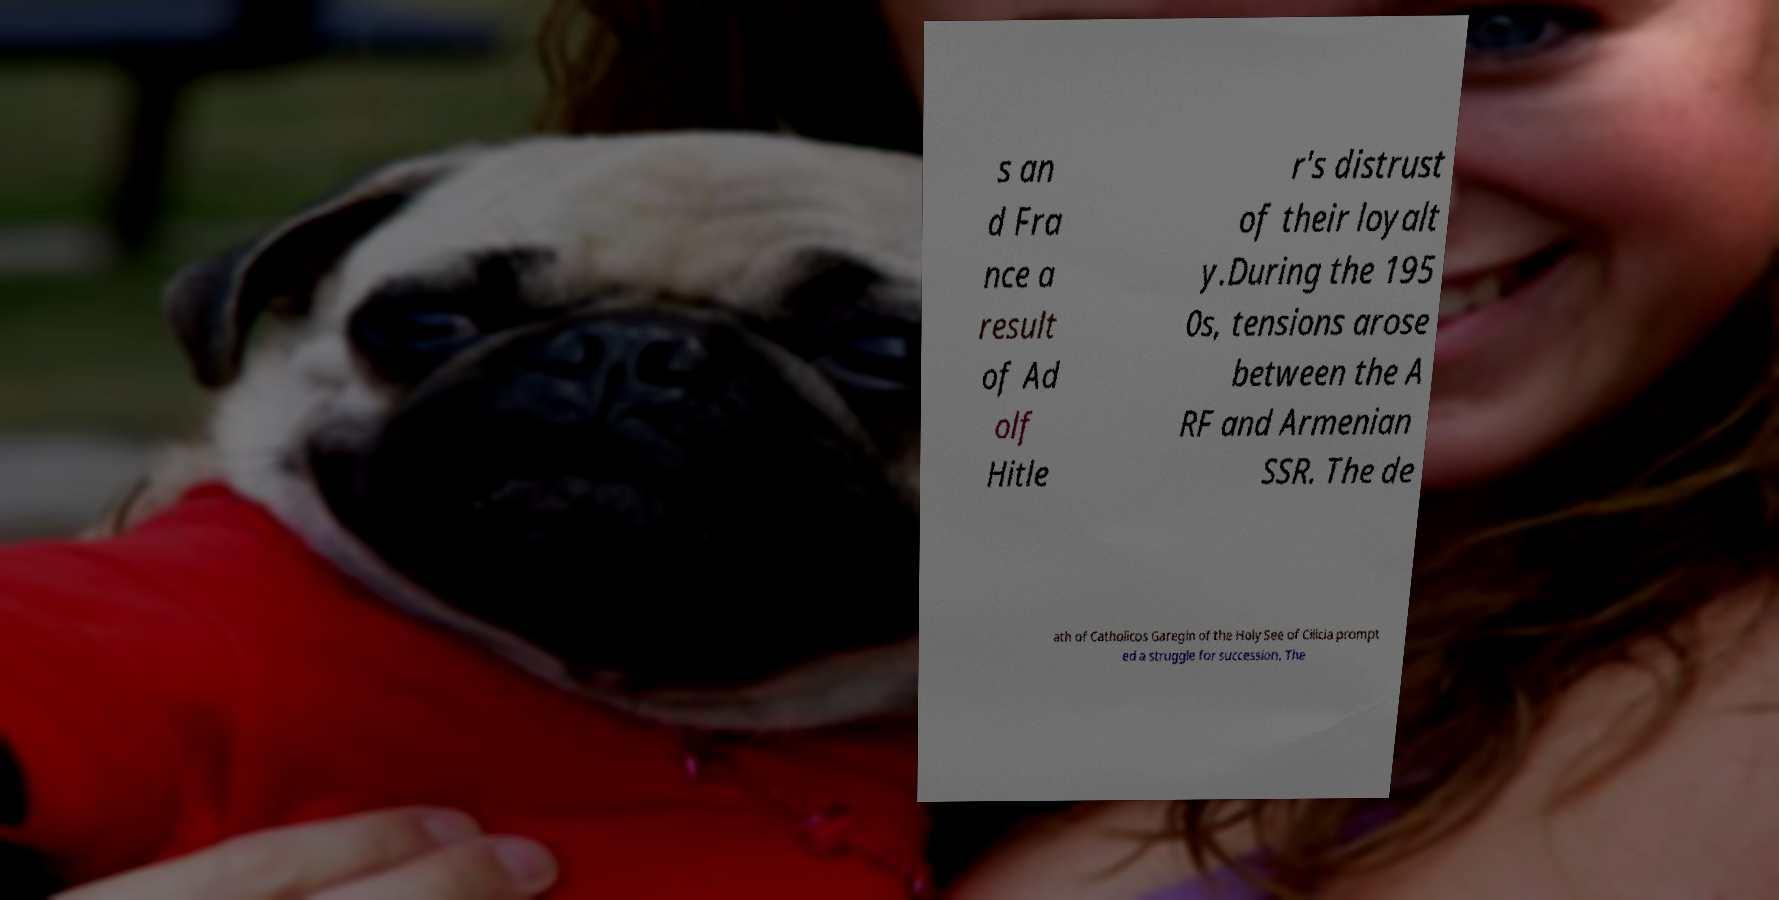There's text embedded in this image that I need extracted. Can you transcribe it verbatim? s an d Fra nce a result of Ad olf Hitle r's distrust of their loyalt y.During the 195 0s, tensions arose between the A RF and Armenian SSR. The de ath of Catholicos Garegin of the Holy See of Cilicia prompt ed a struggle for succession. The 